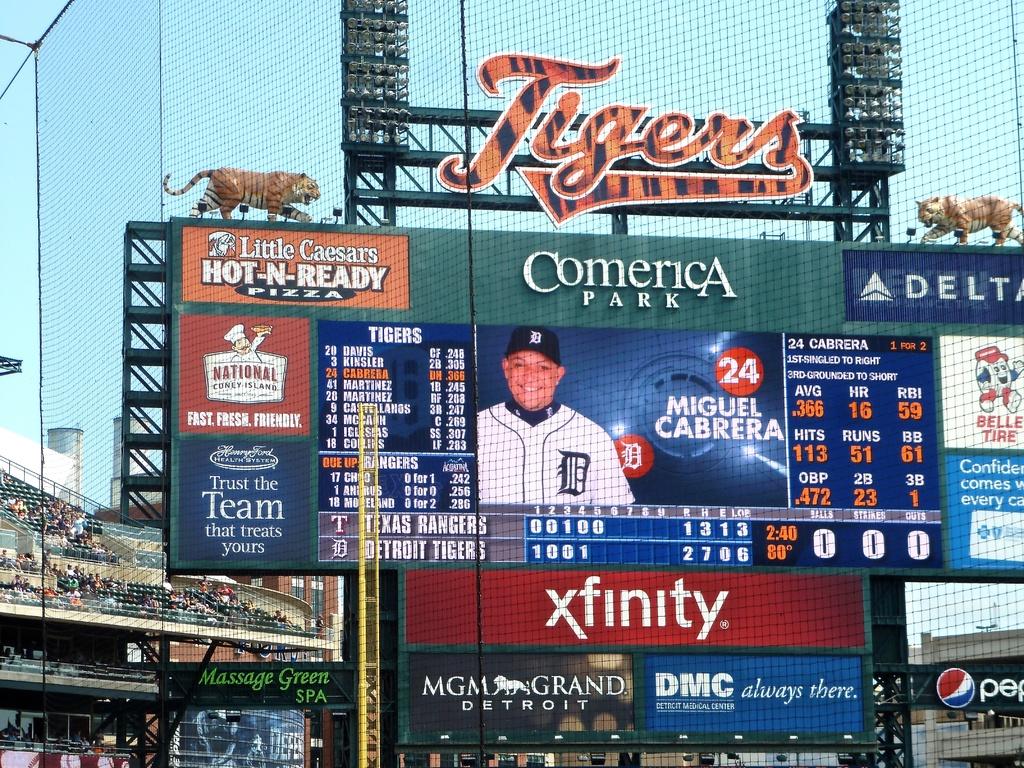Who's home stadium is this?
Provide a short and direct response. Tigers. What is the name of this ballpark?
Provide a succinct answer. Comerica park. 